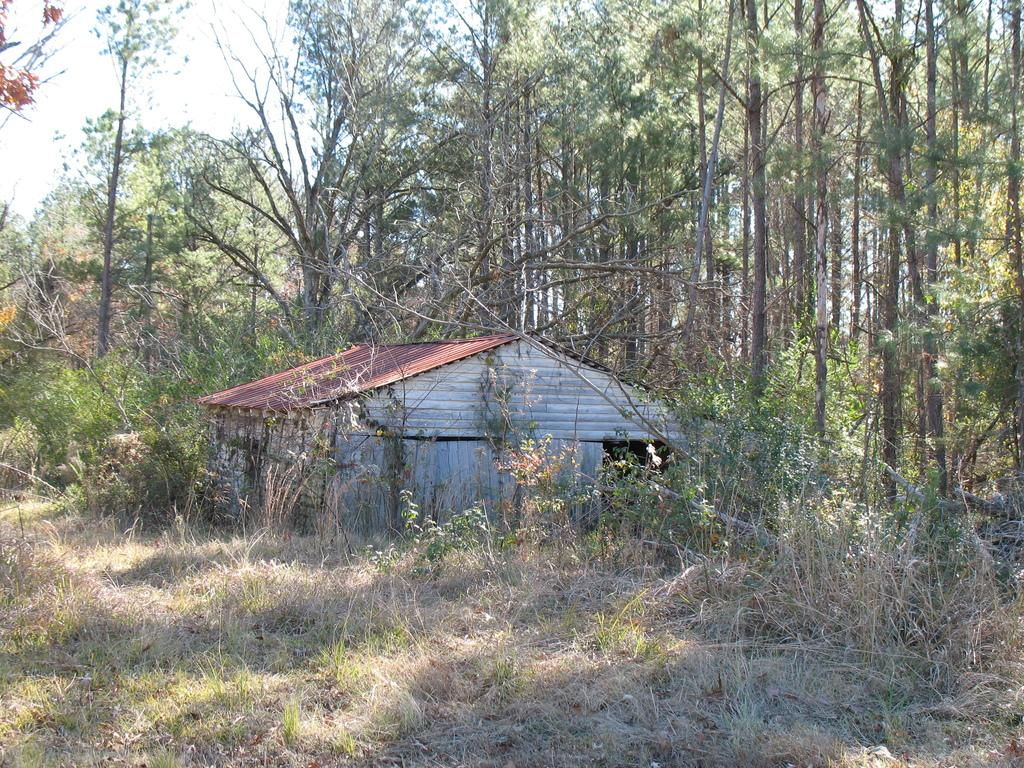What type of vegetation can be seen in the image? There is grass and plants in the image. What type of structure is present in the image? There is a shed in the image. What type of natural elements can be seen in the image? There are trees in the image. What is visible in the background of the image? The sky is visible in the background of the image. What is the topic of the discussion taking place in the image? There is no discussion taking place in the image; it is a still image of grass, plants, a shed, trees, and the sky. Can you see a zipper on any of the plants in the image? There are no zippers present on the plants in the image; plants do not have zippers. 